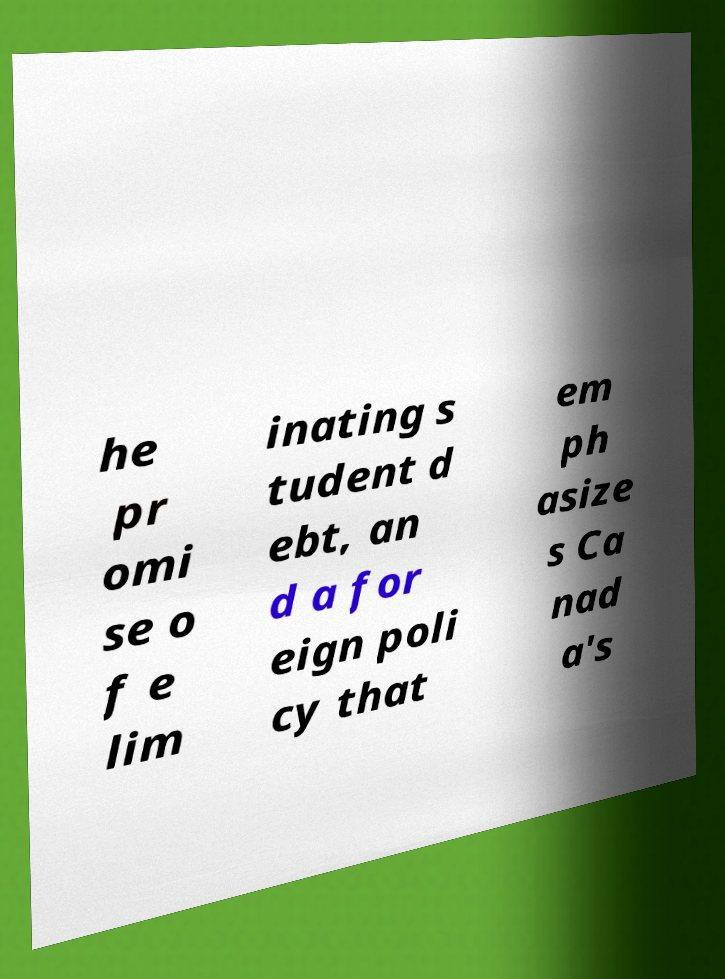For documentation purposes, I need the text within this image transcribed. Could you provide that? he pr omi se o f e lim inating s tudent d ebt, an d a for eign poli cy that em ph asize s Ca nad a's 